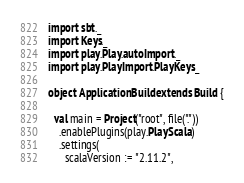Convert code to text. <code><loc_0><loc_0><loc_500><loc_500><_Scala_>import sbt._
import Keys._
import play.Play.autoImport._
import play.PlayImport.PlayKeys._

object ApplicationBuild extends Build {

  val main = Project("root", file("."))
    .enablePlugins(play.PlayScala)
    .settings(
      scalaVersion := "2.11.2",</code> 